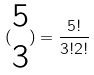Convert formula to latex. <formula><loc_0><loc_0><loc_500><loc_500>( \begin{matrix} 5 \\ 3 \end{matrix} ) = \frac { 5 ! } { 3 ! 2 ! }</formula> 